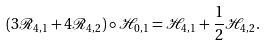<formula> <loc_0><loc_0><loc_500><loc_500>( 3 \mathcal { R } _ { 4 , 1 } + 4 \mathcal { R } _ { 4 , 2 } ) \circ \mathcal { H } _ { 0 , 1 } = \mathcal { H } _ { 4 , 1 } + \frac { 1 } { 2 } \mathcal { H } _ { 4 , 2 } .</formula> 